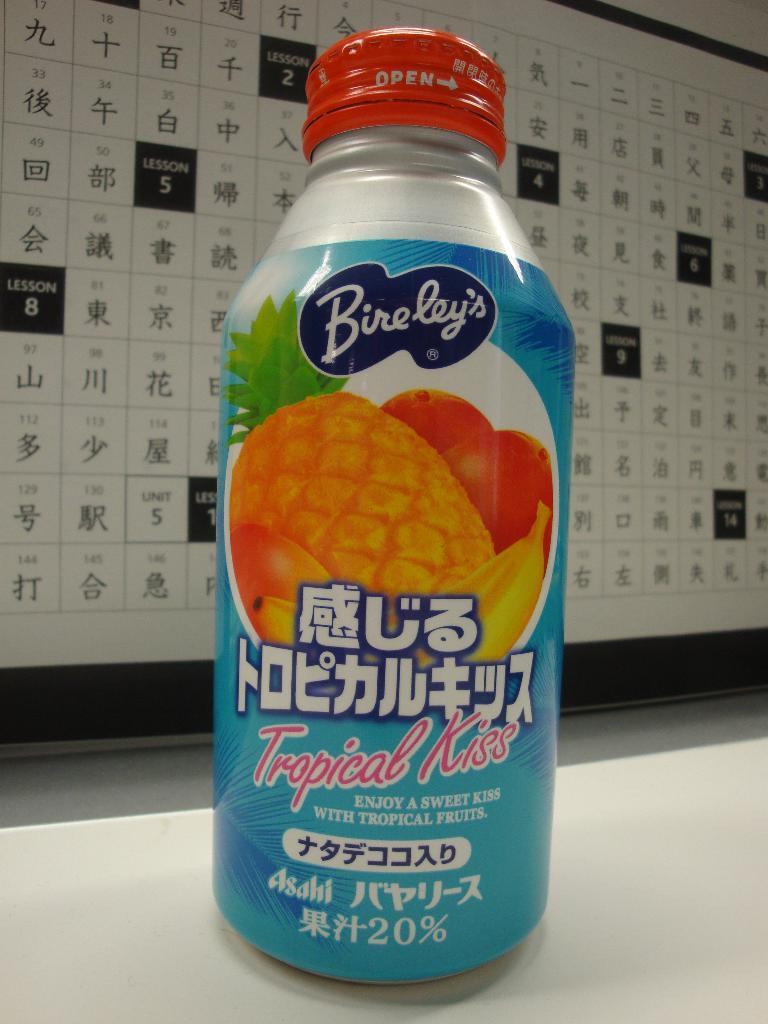<image>
Share a concise interpretation of the image provided. A bottle of Bireley's sitting on a table near a lot of Chinese characters on a wall. 